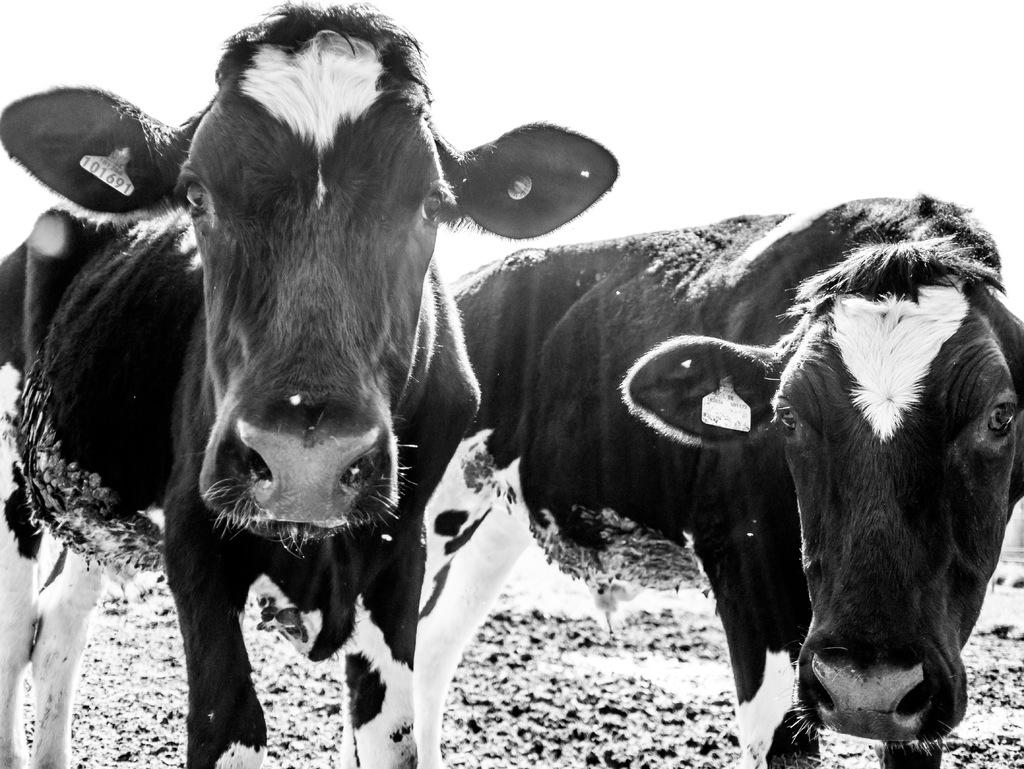How many cows are present in the image? There are two cows in the image. What color are the cows in the image? The cows are in black and white color. What is the overall color scheme of the image? The image is in black and white color. What can be seen on the cows' ears? The cows have tags on their ears. Can you tell me how many guides are present in the image? There are no guides present in the image; it features two cows with tags on their ears. What type of coast can be seen in the image? There is no coast visible in the image; it is a black and white image of two cows. 